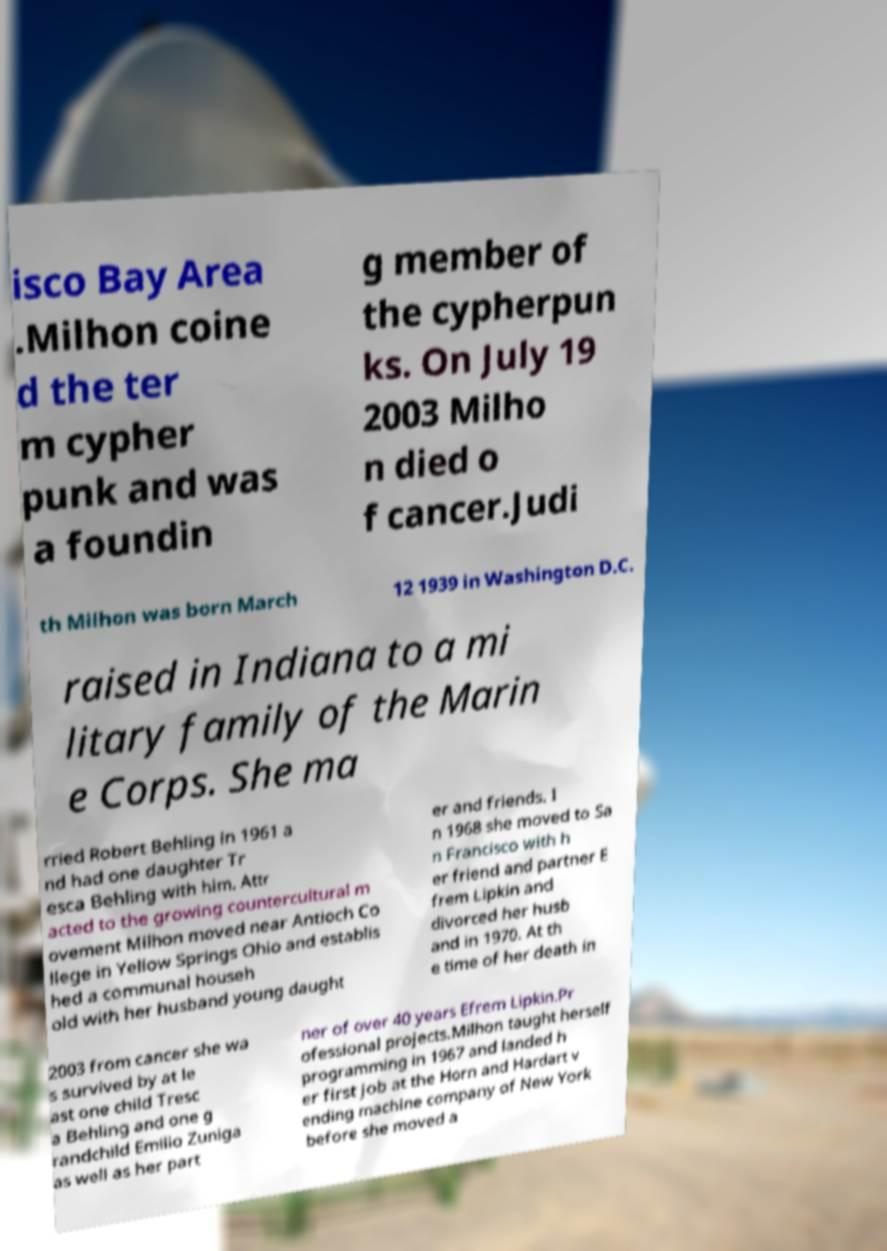Please read and relay the text visible in this image. What does it say? isco Bay Area .Milhon coine d the ter m cypher punk and was a foundin g member of the cypherpun ks. On July 19 2003 Milho n died o f cancer.Judi th Milhon was born March 12 1939 in Washington D.C. raised in Indiana to a mi litary family of the Marin e Corps. She ma rried Robert Behling in 1961 a nd had one daughter Tr esca Behling with him. Attr acted to the growing countercultural m ovement Milhon moved near Antioch Co llege in Yellow Springs Ohio and establis hed a communal househ old with her husband young daught er and friends. I n 1968 she moved to Sa n Francisco with h er friend and partner E frem Lipkin and divorced her husb and in 1970. At th e time of her death in 2003 from cancer she wa s survived by at le ast one child Tresc a Behling and one g randchild Emilio Zuniga as well as her part ner of over 40 years Efrem Lipkin.Pr ofessional projects.Milhon taught herself programming in 1967 and landed h er first job at the Horn and Hardart v ending machine company of New York before she moved a 